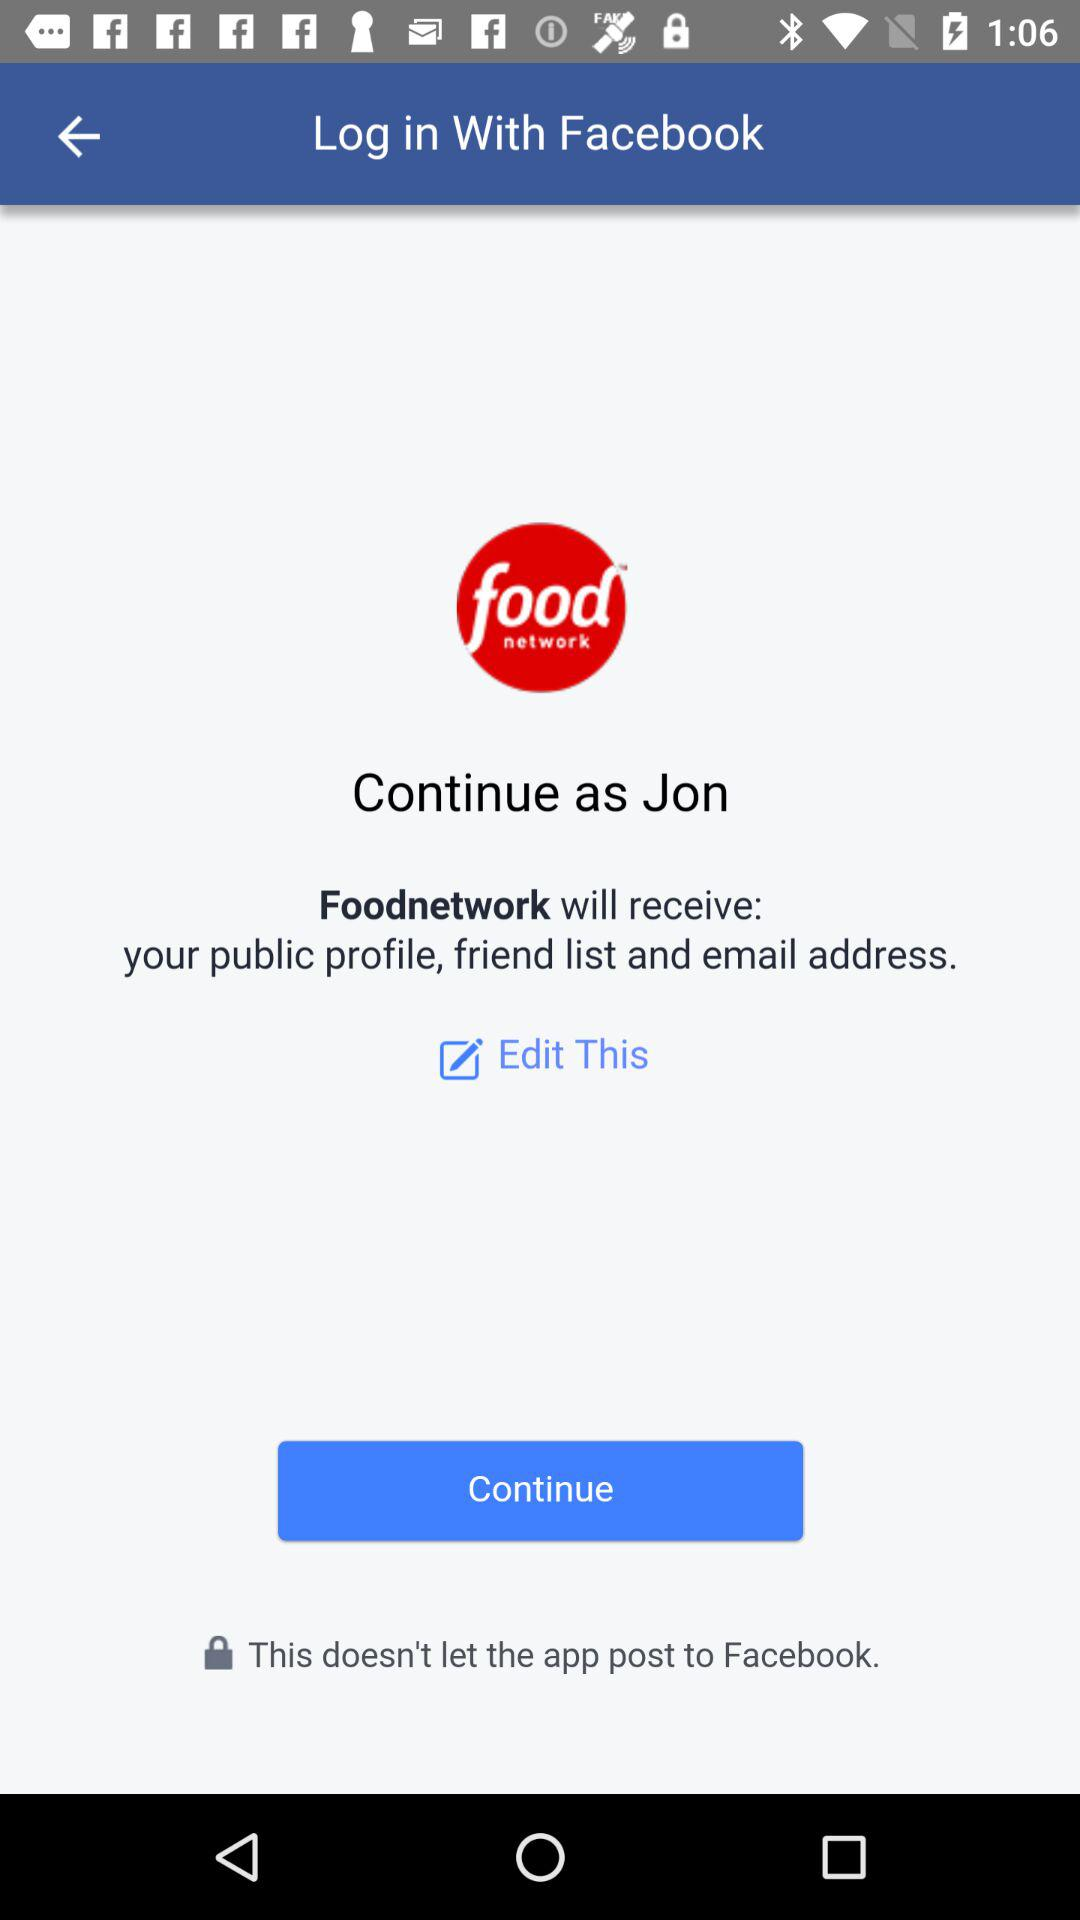What is the name? The name is Jon. 